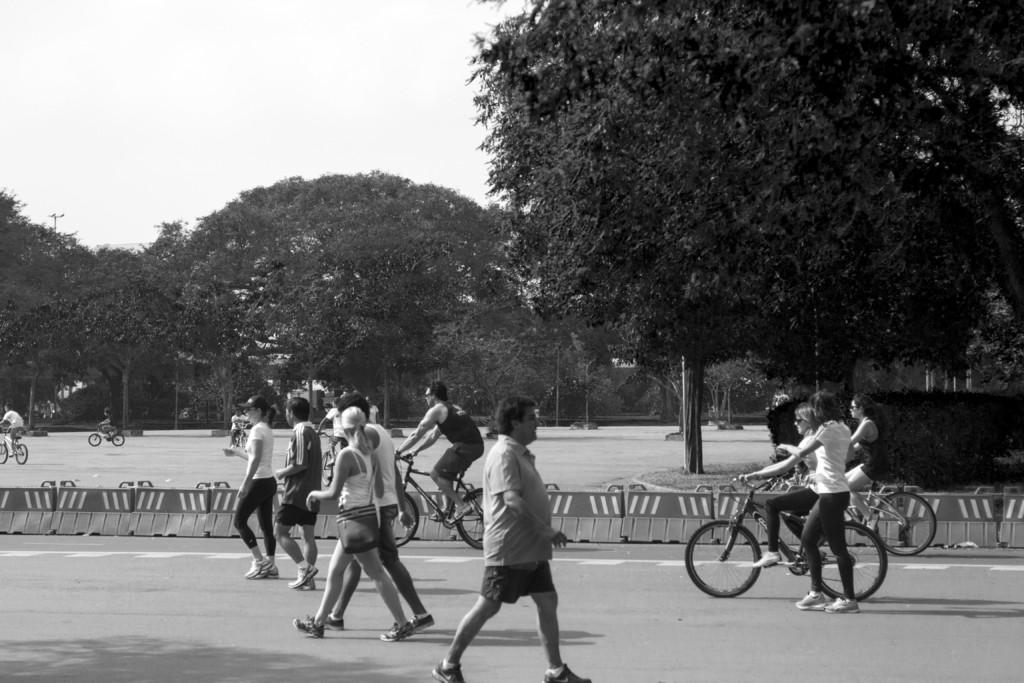Where was the image taken? The image was taken on the road. What are the people in the image doing? Some people are walking on the road, while others are riding bicycles. What can be seen in the background of the image? There are trees and the sky visible in the background of the image. What type of tank can be seen in the image? There is no tank present in the image. How many coaches are visible in the image? There are no coaches present in the image. 